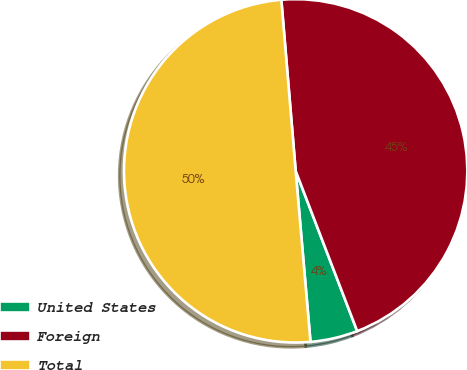Convert chart. <chart><loc_0><loc_0><loc_500><loc_500><pie_chart><fcel>United States<fcel>Foreign<fcel>Total<nl><fcel>4.46%<fcel>45.49%<fcel>50.04%<nl></chart> 